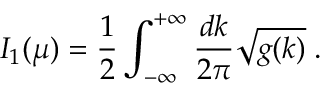Convert formula to latex. <formula><loc_0><loc_0><loc_500><loc_500>I _ { 1 } ( \mu ) = { \frac { 1 } { 2 } } \int _ { - \infty } ^ { + \infty } \frac { d k } { 2 \pi } { \sqrt { g ( k ) } } \, .</formula> 